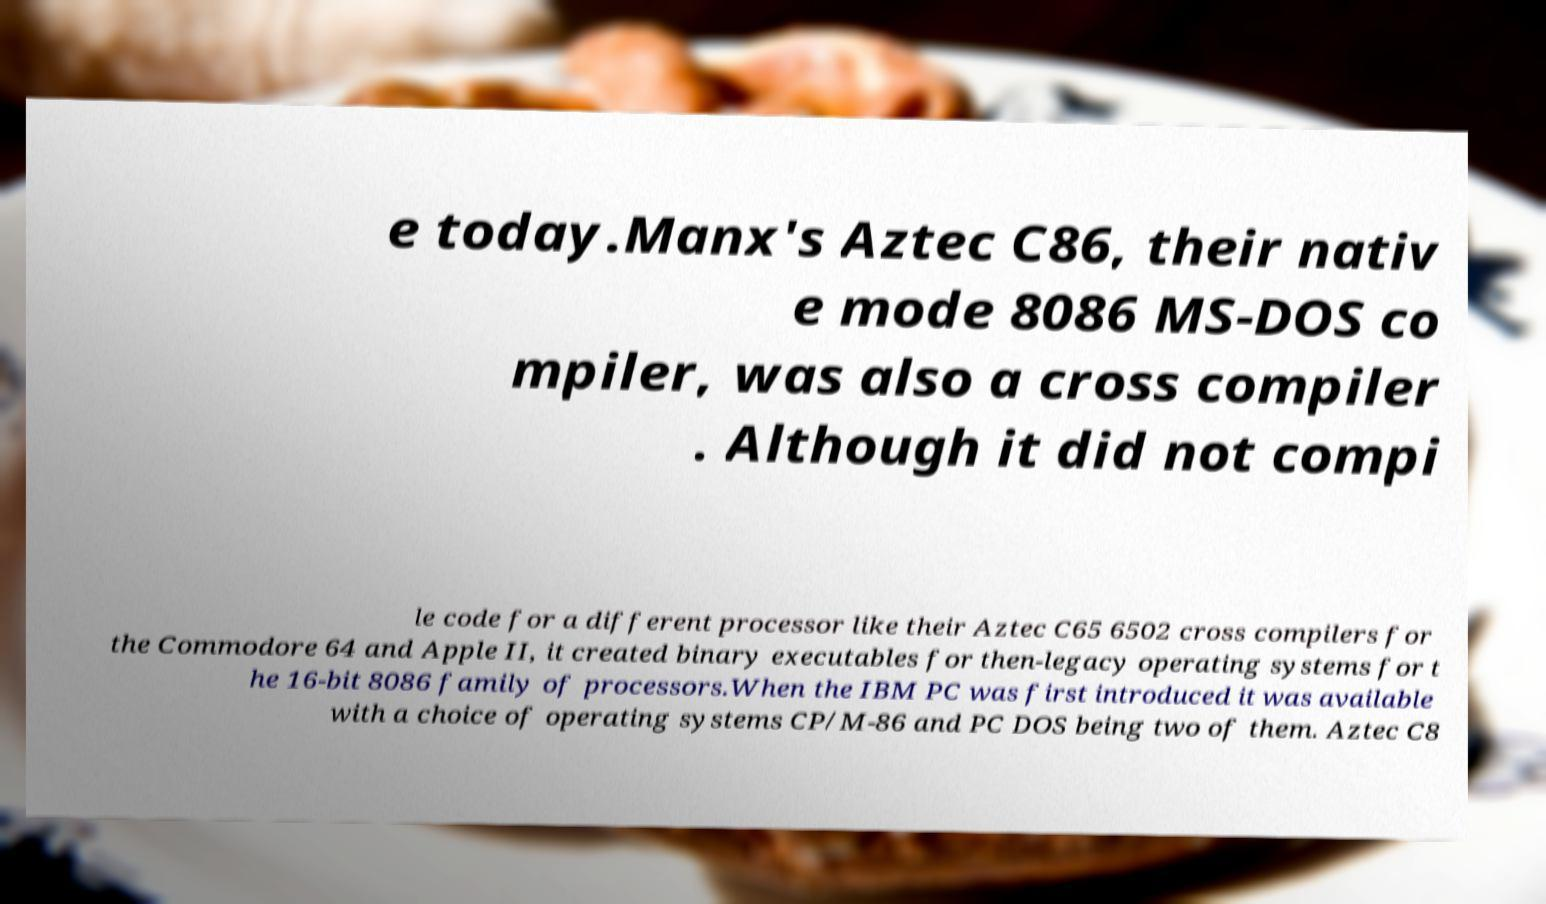What messages or text are displayed in this image? I need them in a readable, typed format. e today.Manx's Aztec C86, their nativ e mode 8086 MS-DOS co mpiler, was also a cross compiler . Although it did not compi le code for a different processor like their Aztec C65 6502 cross compilers for the Commodore 64 and Apple II, it created binary executables for then-legacy operating systems for t he 16-bit 8086 family of processors.When the IBM PC was first introduced it was available with a choice of operating systems CP/M-86 and PC DOS being two of them. Aztec C8 